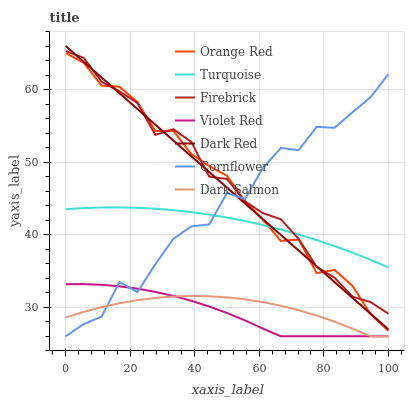Does Violet Red have the minimum area under the curve?
Answer yes or no. Yes. Does Firebrick have the maximum area under the curve?
Answer yes or no. Yes. Does Turquoise have the minimum area under the curve?
Answer yes or no. No. Does Turquoise have the maximum area under the curve?
Answer yes or no. No. Is Dark Red the smoothest?
Answer yes or no. Yes. Is Cornflower the roughest?
Answer yes or no. Yes. Is Turquoise the smoothest?
Answer yes or no. No. Is Turquoise the roughest?
Answer yes or no. No. Does Dark Red have the lowest value?
Answer yes or no. No. Does Turquoise have the highest value?
Answer yes or no. No. Is Violet Red less than Turquoise?
Answer yes or no. Yes. Is Firebrick greater than Violet Red?
Answer yes or no. Yes. Does Violet Red intersect Turquoise?
Answer yes or no. No. 